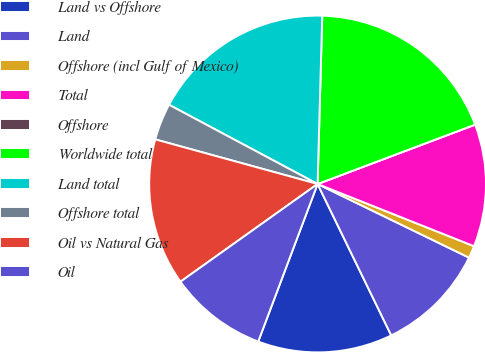Convert chart to OTSL. <chart><loc_0><loc_0><loc_500><loc_500><pie_chart><fcel>Land vs Offshore<fcel>Land<fcel>Offshore (incl Gulf of Mexico)<fcel>Total<fcel>Offshore<fcel>Worldwide total<fcel>Land total<fcel>Offshore total<fcel>Oil vs Natural Gas<fcel>Oil<nl><fcel>12.94%<fcel>10.59%<fcel>1.18%<fcel>11.76%<fcel>0.0%<fcel>18.82%<fcel>17.64%<fcel>3.53%<fcel>14.12%<fcel>9.41%<nl></chart> 